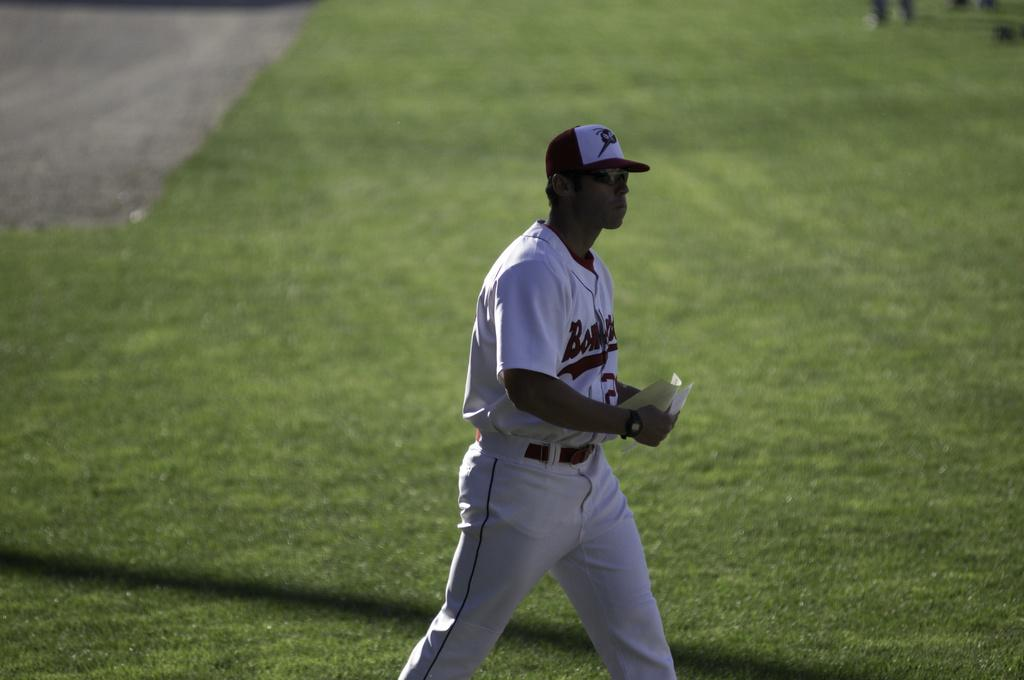<image>
Summarize the visual content of the image. The baseball player had an outfit that starts with the letters "Bom". 